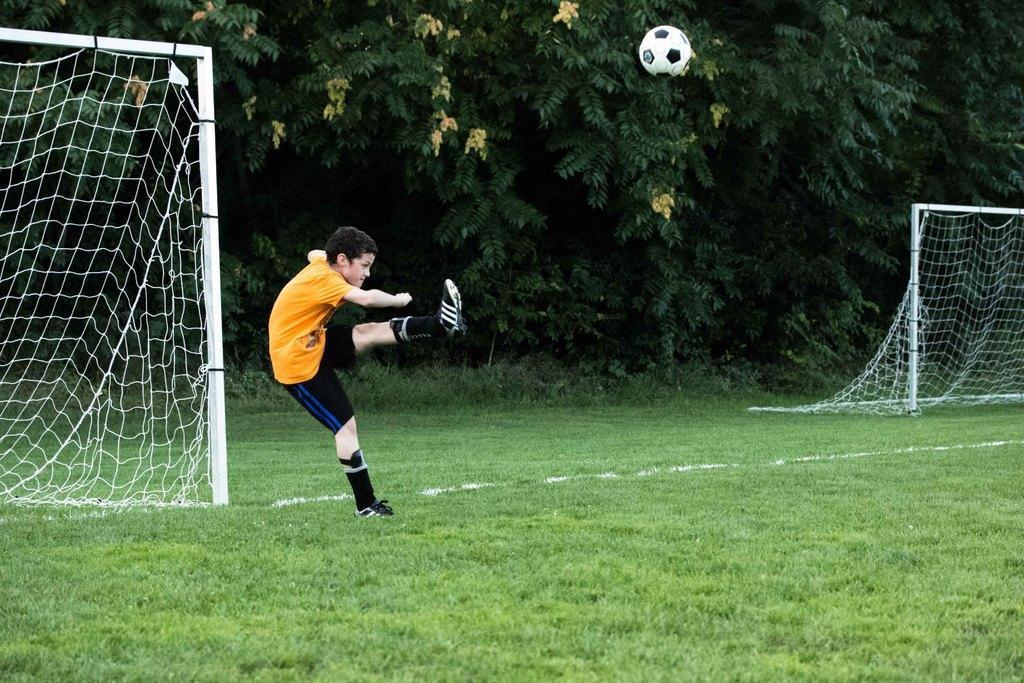Describe this image in one or two sentences. In this image, I can see a boy standing on his leg. This is a football flying in the air. Here is the grass. These are the football goal posts. In the background, I can see the trees. 